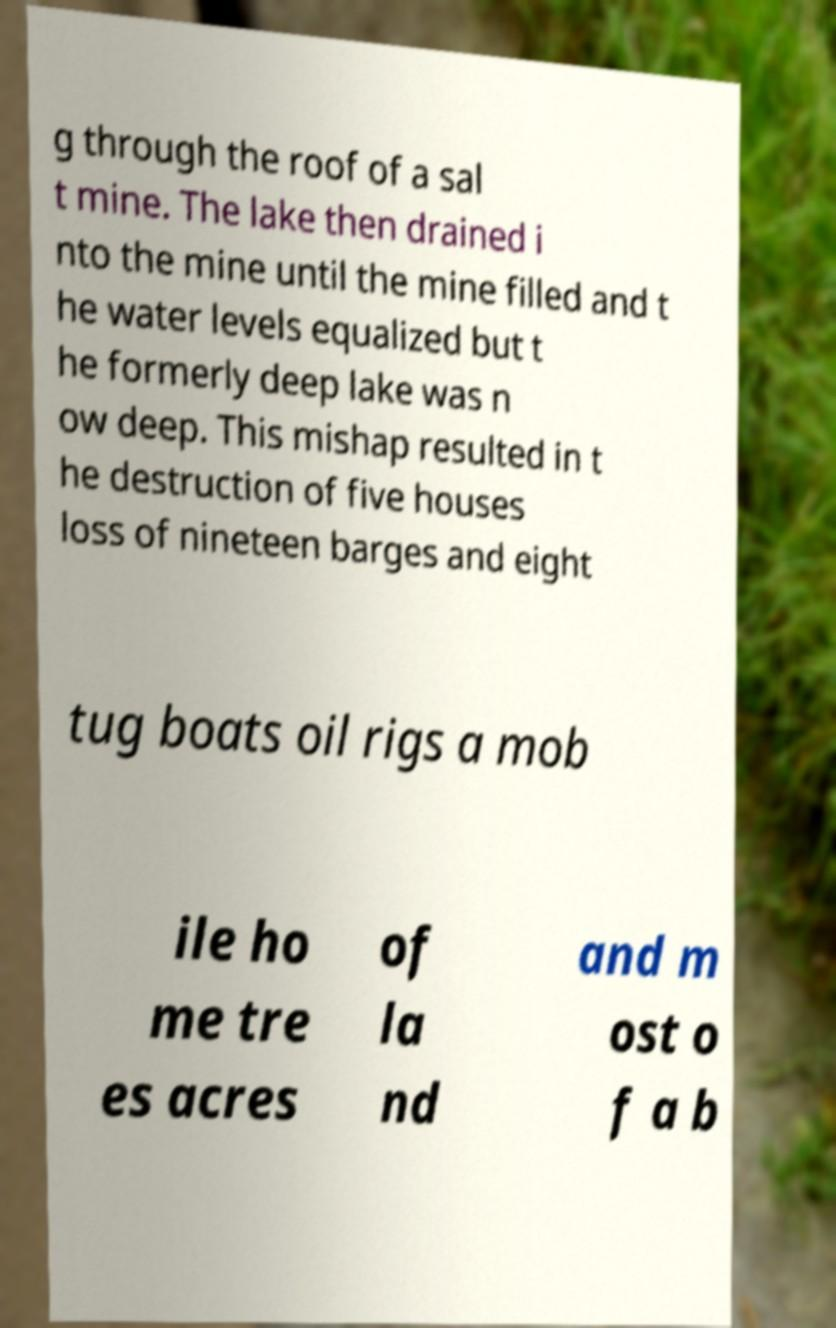What messages or text are displayed in this image? I need them in a readable, typed format. g through the roof of a sal t mine. The lake then drained i nto the mine until the mine filled and t he water levels equalized but t he formerly deep lake was n ow deep. This mishap resulted in t he destruction of five houses loss of nineteen barges and eight tug boats oil rigs a mob ile ho me tre es acres of la nd and m ost o f a b 